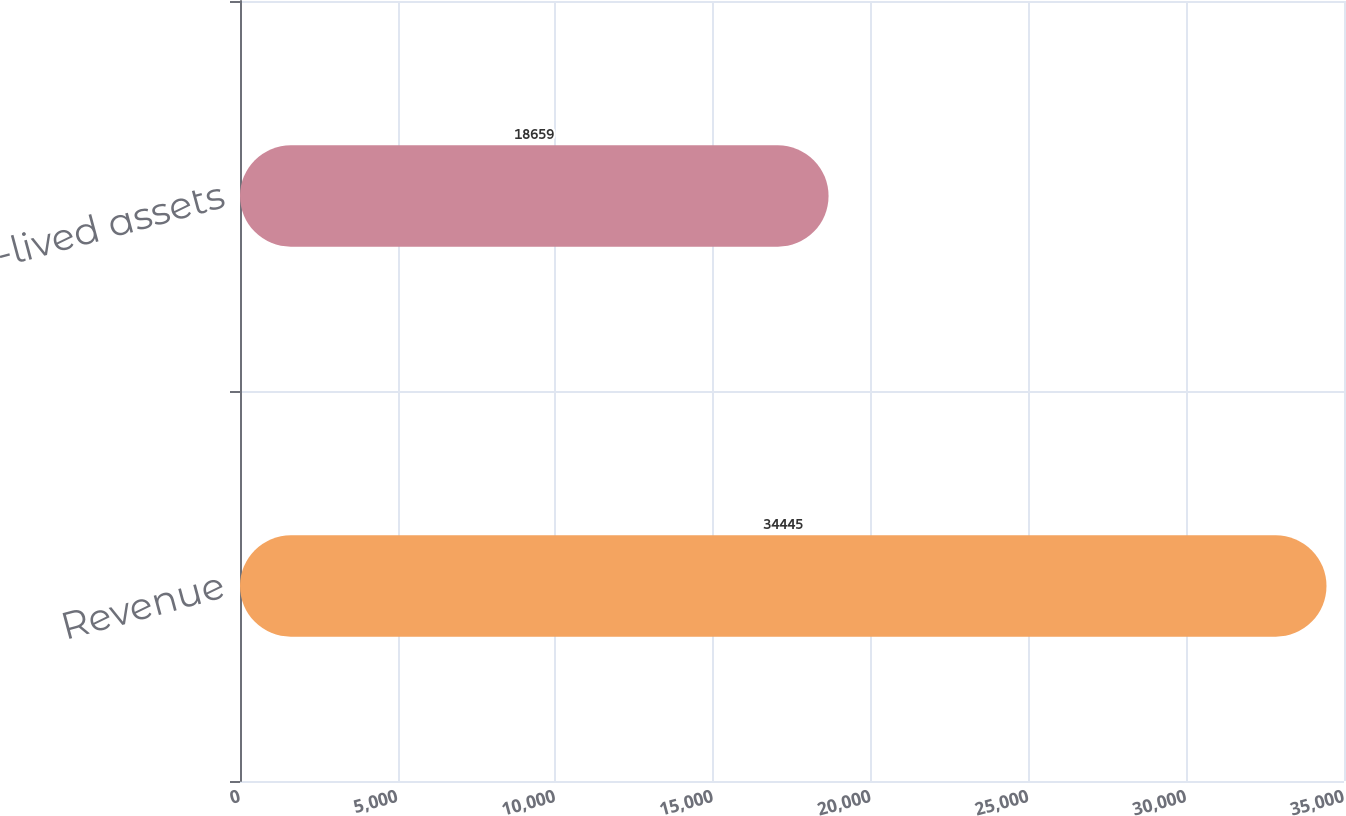Convert chart. <chart><loc_0><loc_0><loc_500><loc_500><bar_chart><fcel>Revenue<fcel>Long-lived assets<nl><fcel>34445<fcel>18659<nl></chart> 